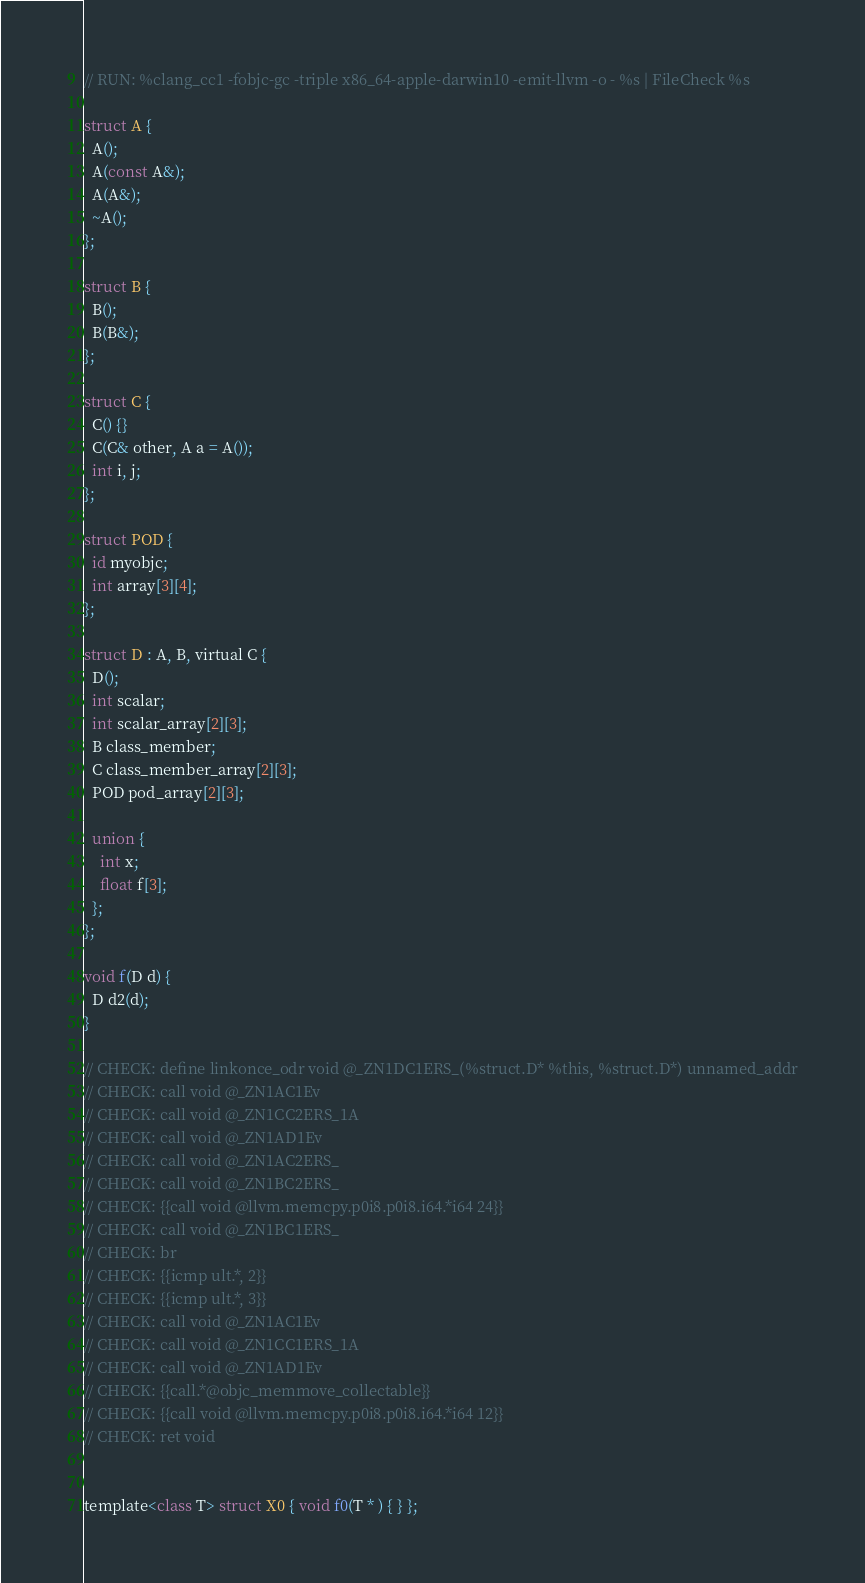Convert code to text. <code><loc_0><loc_0><loc_500><loc_500><_ObjectiveC_>// RUN: %clang_cc1 -fobjc-gc -triple x86_64-apple-darwin10 -emit-llvm -o - %s | FileCheck %s

struct A { 
  A();
  A(const A&);
  A(A&);
  ~A();
};

struct B {
  B();
  B(B&);
};

struct C {
  C() {}
  C(C& other, A a = A());
  int i, j;
};

struct POD {
  id myobjc;
  int array[3][4];
};

struct D : A, B, virtual C { 
  D();
  int scalar;
  int scalar_array[2][3];
  B class_member;
  C class_member_array[2][3];
  POD pod_array[2][3];

  union {
    int x;
    float f[3];
  };
};

void f(D d) {
  D d2(d);
}

// CHECK: define linkonce_odr void @_ZN1DC1ERS_(%struct.D* %this, %struct.D*) unnamed_addr
// CHECK: call void @_ZN1AC1Ev
// CHECK: call void @_ZN1CC2ERS_1A
// CHECK: call void @_ZN1AD1Ev
// CHECK: call void @_ZN1AC2ERS_
// CHECK: call void @_ZN1BC2ERS_
// CHECK: {{call void @llvm.memcpy.p0i8.p0i8.i64.*i64 24}}
// CHECK: call void @_ZN1BC1ERS_
// CHECK: br
// CHECK: {{icmp ult.*, 2}}
// CHECK: {{icmp ult.*, 3}}
// CHECK: call void @_ZN1AC1Ev
// CHECK: call void @_ZN1CC1ERS_1A
// CHECK: call void @_ZN1AD1Ev
// CHECK: {{call.*@objc_memmove_collectable}}
// CHECK: {{call void @llvm.memcpy.p0i8.p0i8.i64.*i64 12}}
// CHECK: ret void


template<class T> struct X0 { void f0(T * ) { } };</code> 